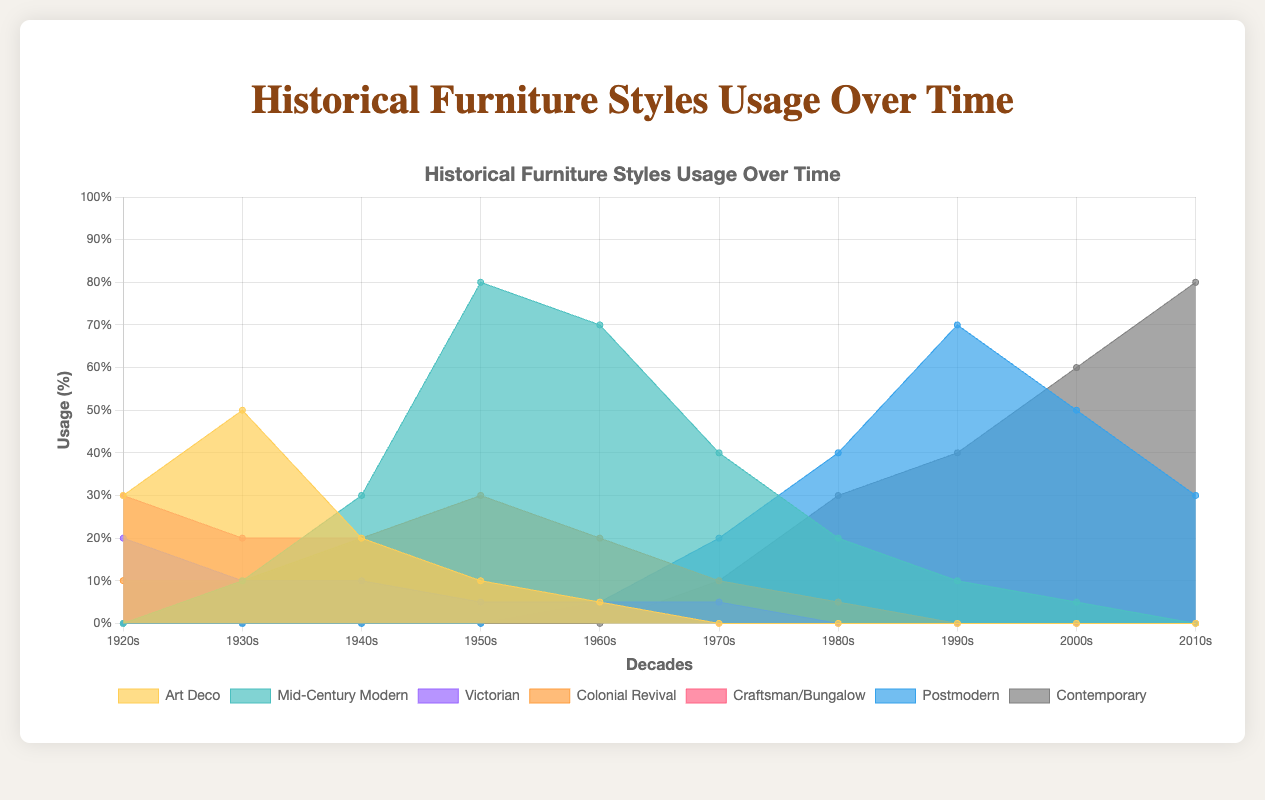What is the highest percentage usage of the 'Art Deco' style and in which decade did it occur? The highest percentage usage of the 'Art Deco' style is 0.5, which occurred in the 1930s.
Answer: 0.5, 1930s Which furniture style shows a gradual increase in usage from the 1960s to the 2010s? The 'Contemporary' style shows a gradual increase in usage from the 1960s, starting at 0, and reaching 0.8 in the 2010s.
Answer: Contemporary How does the usage of 'Mid-Century Modern' in the 1950s compare to its usage in the 2010s? In the 1950s, the usage of 'Mid-Century Modern' was 0.8, while in the 2010s, it was 0%. The usage was significantly higher in the 1950s.
Answer: Higher in the 1950s What is the total combined usage percentage of 'Craftsman/Bungalow' and 'Colonial Revival' in the 1920s? The usage of 'Craftsman/Bungalow' in the 1920s is 0.3, and 'Colonial Revival' is 0.1. The combined usage is 0.3 + 0.1 = 0.4.
Answer: 0.4 Which style had the lowest usage in the 1970s and what was the percentage? In the 1970s, the 'Art Deco' style had the lowest usage, with a percentage of 0%.
Answer: Art Deco, 0% How does the trend of 'Postmodern' style from the 1960s to the 2010s compare to that of the 'Victorian' style over the same period? The 'Postmodern' style increased from 0.05 in the 1960s to 0.3 in the 2010s, while the 'Victorian' style was steady at around 0.05 or lower. 'Postmodern' shows an increasing trend, whereas 'Victorian' remains relatively stable and low.
Answer: Postmodern is increasing, Victorian is stable What decade saw the peak usage of the 'Mid-Century Modern' style, and what percentage was it? The 'Mid-Century Modern' style peaked in the 1950s with a usage of 0.8.
Answer: 1950s, 0.8 Which two styles had similar usage percentages in the 1940s, and what were those percentages? In the 1940s, the 'Victorian' and 'Craftsman/Bungalow' styles both had usage percentages of 0.2.
Answer: Victorian and Craftsman/Bungalow, 0.2 Which style shows the most significant upward trend in usage after the 1980s? 'Contemporary' shows the most significant upward trend in usage after the 1980s, increasing from 0.1 to 0.8 from the 1980s to 2010s.
Answer: Contemporary Between 'Colonial Revival' and 'Postmodern' styles, which one had higher usage in the 1990s and what were their percentages? In the 1990s, 'Postmodern' had a higher usage at 0.7, compared to 'Colonial Revival' which had 0%.
Answer: Postmodern, 0.7 